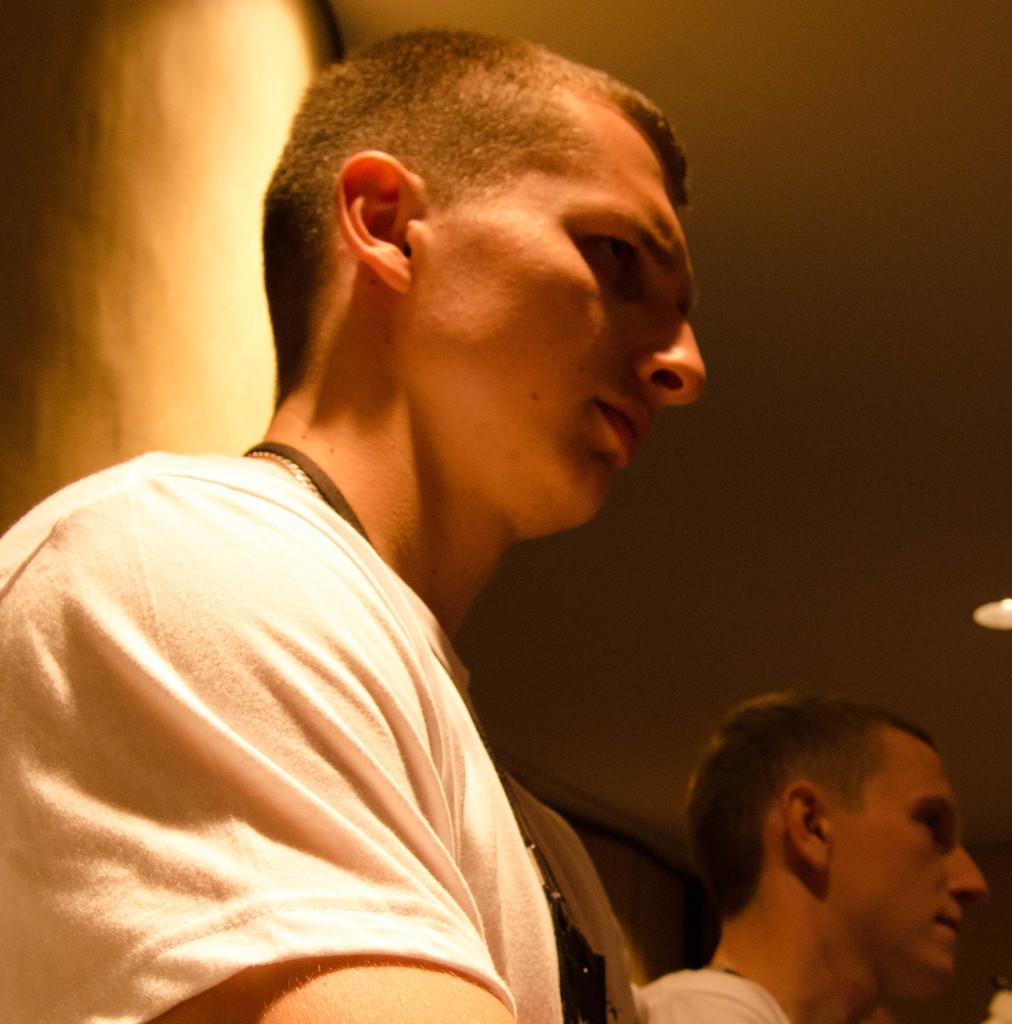How many people are in the image? There are two men in the image. Can you describe any accessories worn by the men? One of the men is wearing a chain, and the other man is wearing an ID tag. What can be seen in the background of the image? There is a wall and a light in the background of the image. What type of toy is being played with by the men in the image? There is no toy present in the image; the men are not engaged in any playful activity. What kind of cloth is draped over the wall in the image? There is no cloth draped over the wall in the image; the wall is visible without any additional coverings. 